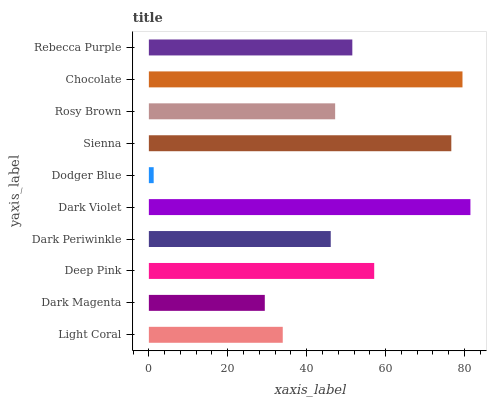Is Dodger Blue the minimum?
Answer yes or no. Yes. Is Dark Violet the maximum?
Answer yes or no. Yes. Is Dark Magenta the minimum?
Answer yes or no. No. Is Dark Magenta the maximum?
Answer yes or no. No. Is Light Coral greater than Dark Magenta?
Answer yes or no. Yes. Is Dark Magenta less than Light Coral?
Answer yes or no. Yes. Is Dark Magenta greater than Light Coral?
Answer yes or no. No. Is Light Coral less than Dark Magenta?
Answer yes or no. No. Is Rebecca Purple the high median?
Answer yes or no. Yes. Is Rosy Brown the low median?
Answer yes or no. Yes. Is Dark Magenta the high median?
Answer yes or no. No. Is Chocolate the low median?
Answer yes or no. No. 